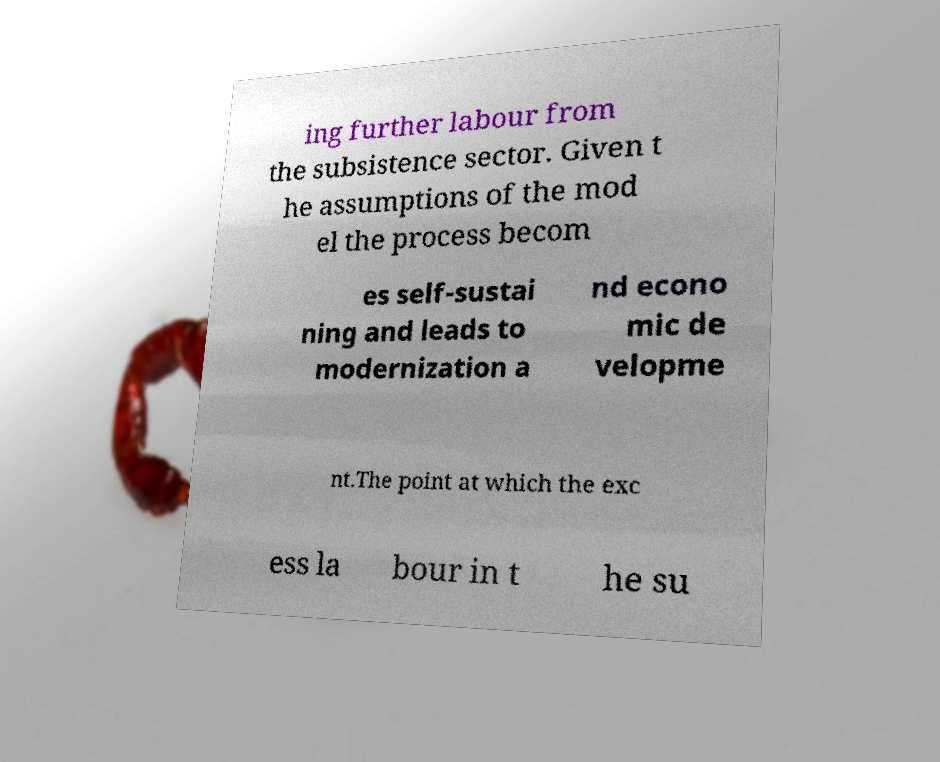What messages or text are displayed in this image? I need them in a readable, typed format. ing further labour from the subsistence sector. Given t he assumptions of the mod el the process becom es self-sustai ning and leads to modernization a nd econo mic de velopme nt.The point at which the exc ess la bour in t he su 